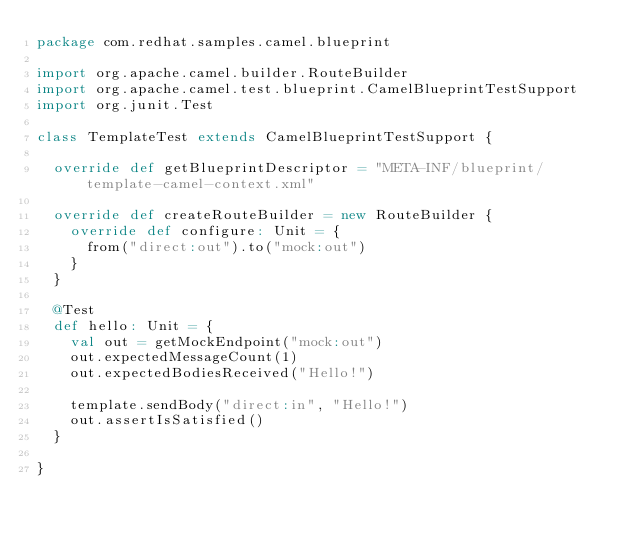<code> <loc_0><loc_0><loc_500><loc_500><_Scala_>package com.redhat.samples.camel.blueprint

import org.apache.camel.builder.RouteBuilder
import org.apache.camel.test.blueprint.CamelBlueprintTestSupport
import org.junit.Test

class TemplateTest extends CamelBlueprintTestSupport {

  override def getBlueprintDescriptor = "META-INF/blueprint/template-camel-context.xml"

  override def createRouteBuilder = new RouteBuilder {
    override def configure: Unit = {
      from("direct:out").to("mock:out")
    }
  }

  @Test
  def hello: Unit = {
    val out = getMockEndpoint("mock:out")
    out.expectedMessageCount(1)
    out.expectedBodiesReceived("Hello!")

    template.sendBody("direct:in", "Hello!")
    out.assertIsSatisfied()
  }

}
</code> 